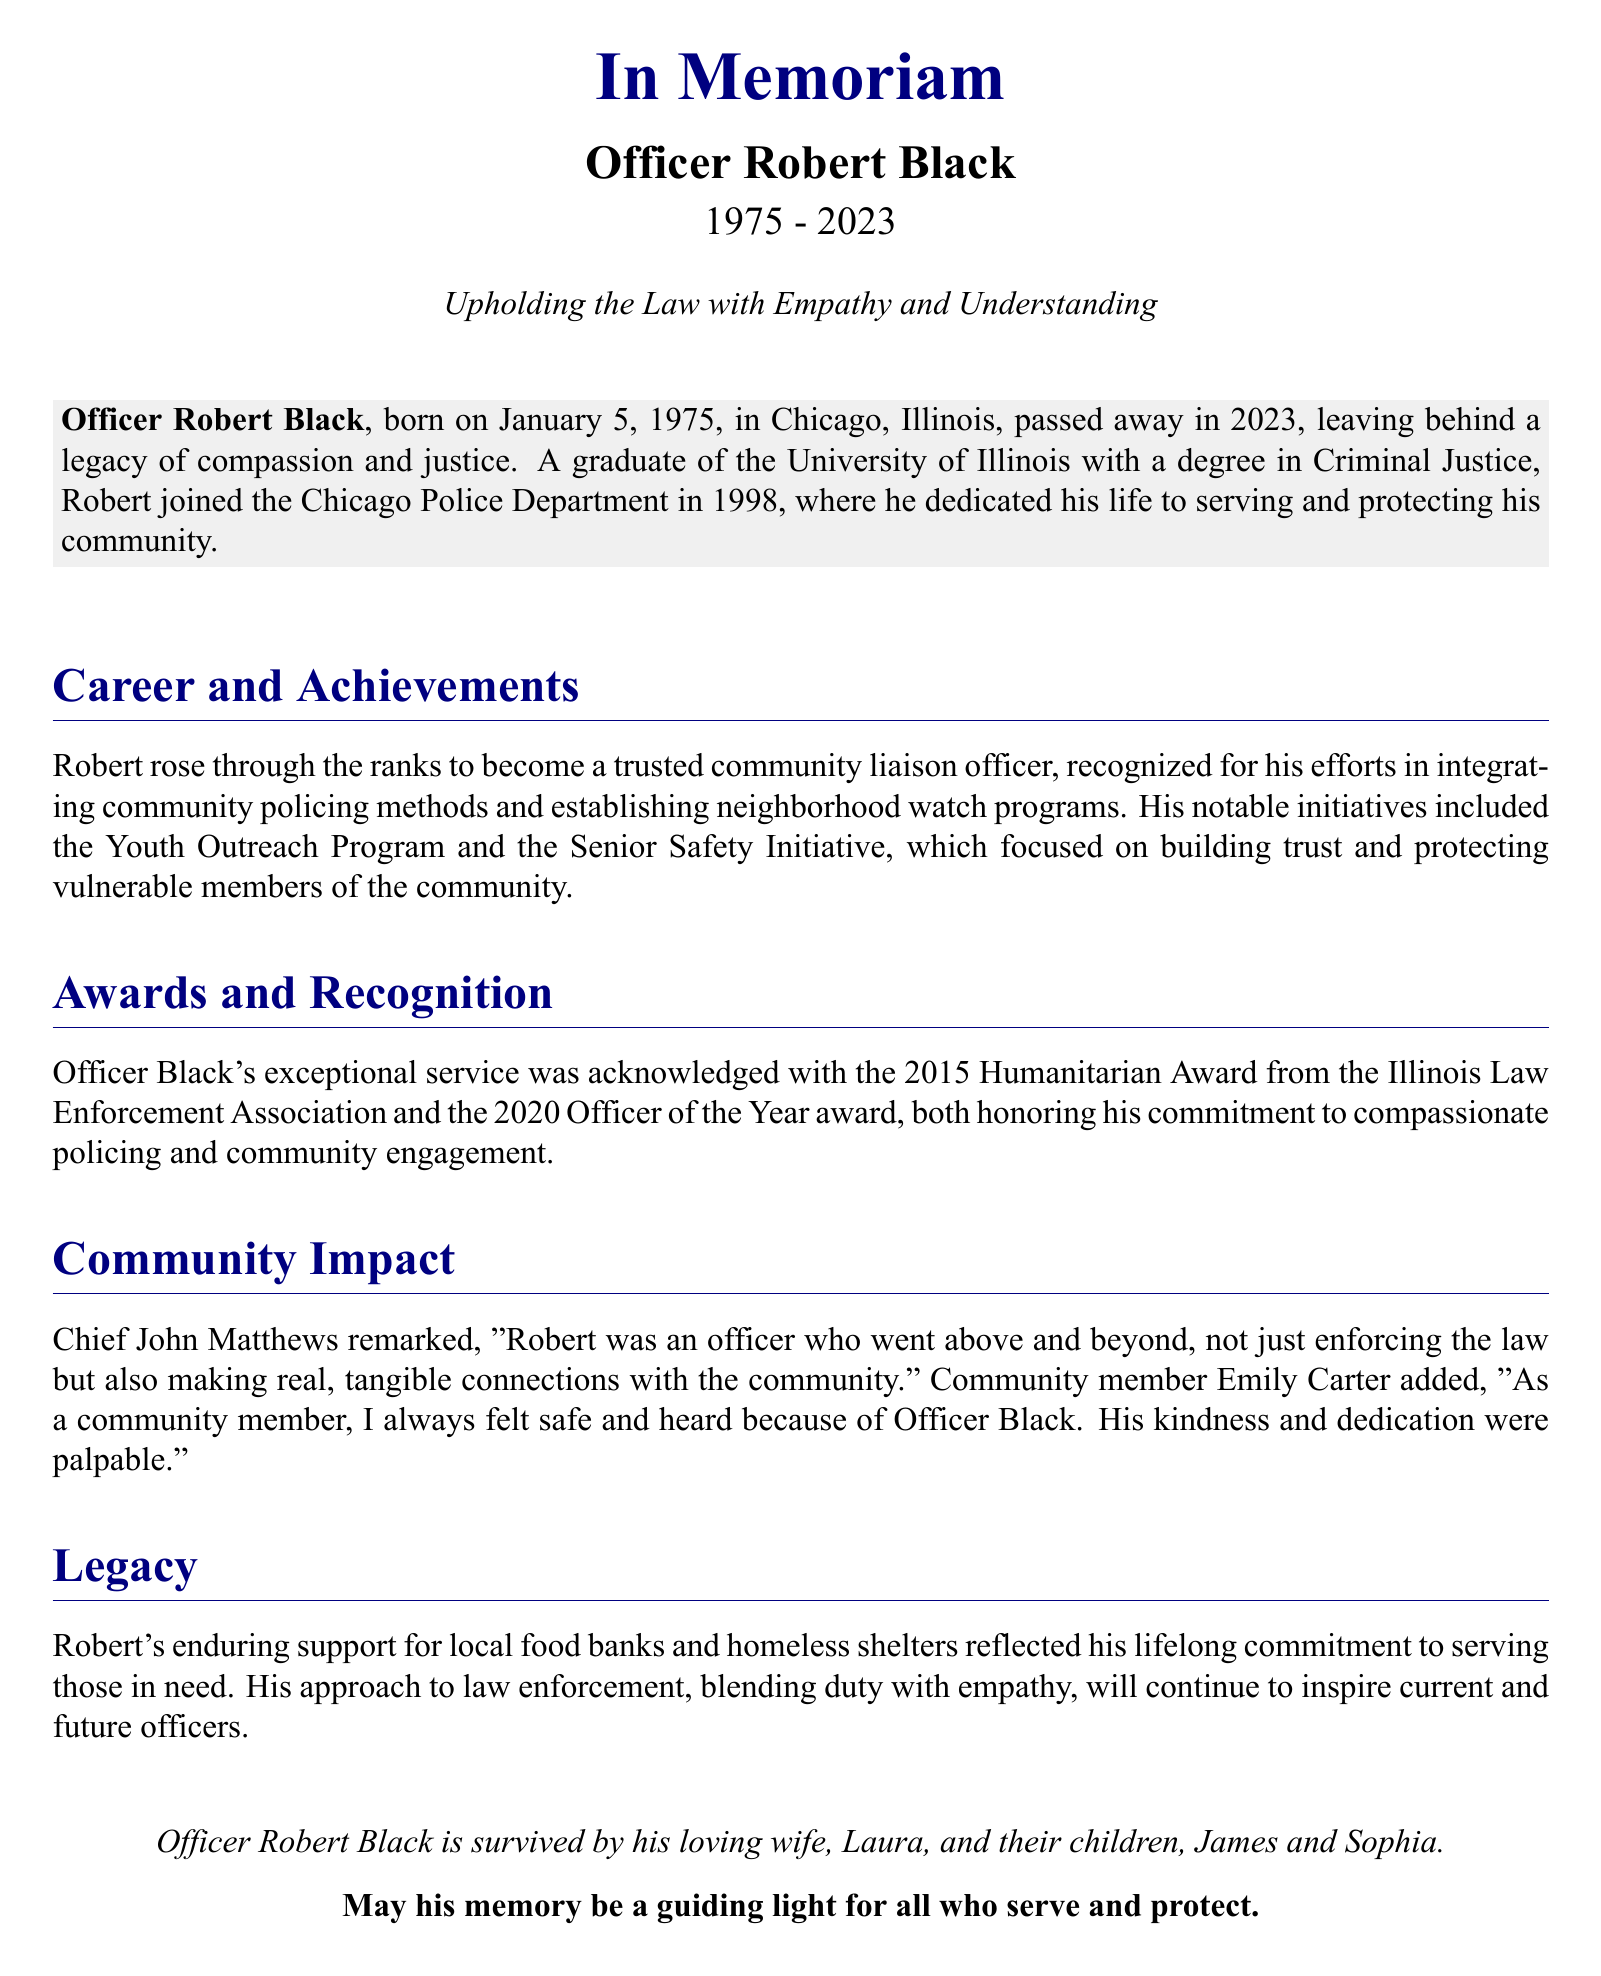What year was Officer Robert Black born? Officer Black was born on January 5, 1975.
Answer: 1975 What award did Officer Black receive in 2015? He received the Humanitarian Award from the Illinois Law Enforcement Association in 2015.
Answer: Humanitarian Award What was one of the notable initiatives launched by Officer Black? The Youth Outreach Program is one of the notable initiatives he created.
Answer: Youth Outreach Program Which city did Officer Black serve as a police officer? The document states he joined the Chicago Police Department.
Answer: Chicago Who is mentioned as a community member in the document? Emily Carter is specifically mentioned as a community member.
Answer: Emily Carter What was Officer Black's profession? He was honored as an officer in the document, specifically as a police officer.
Answer: Officer What is emphasized about Officer Black's approach to law enforcement? The document highlights his approach of blending duty with empathy.
Answer: Empathy What is stated about Officer Black's educational background? He graduated from the University of Illinois with a degree in Criminal Justice.
Answer: Criminal Justice 